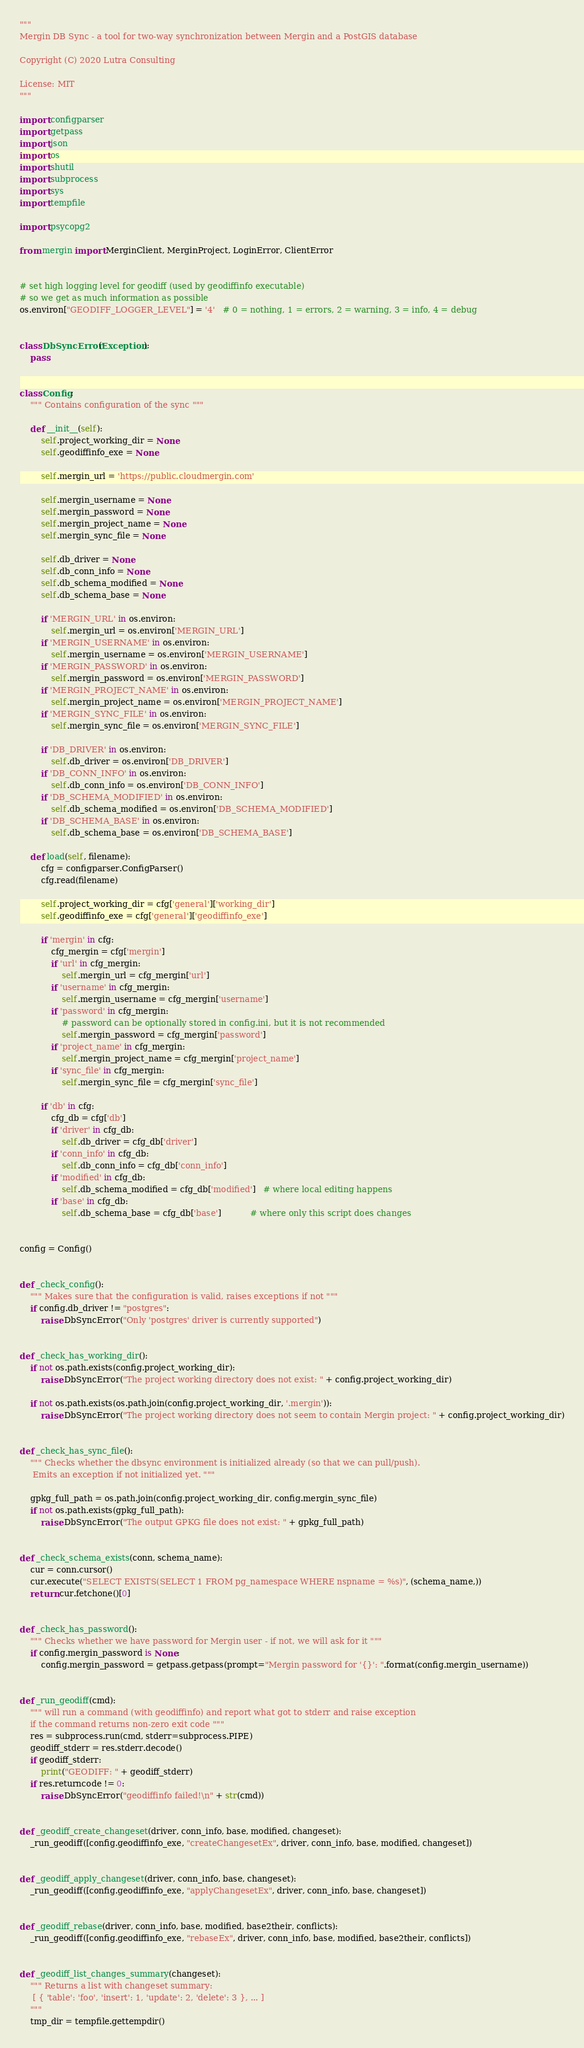<code> <loc_0><loc_0><loc_500><loc_500><_Python_>"""
Mergin DB Sync - a tool for two-way synchronization between Mergin and a PostGIS database

Copyright (C) 2020 Lutra Consulting

License: MIT
"""

import configparser
import getpass
import json
import os
import shutil
import subprocess
import sys
import tempfile

import psycopg2

from mergin import MerginClient, MerginProject, LoginError, ClientError


# set high logging level for geodiff (used by geodiffinfo executable)
# so we get as much information as possible
os.environ["GEODIFF_LOGGER_LEVEL"] = '4'   # 0 = nothing, 1 = errors, 2 = warning, 3 = info, 4 = debug


class DbSyncError(Exception):
    pass


class Config:
    """ Contains configuration of the sync """

    def __init__(self):
        self.project_working_dir = None
        self.geodiffinfo_exe = None

        self.mergin_url = 'https://public.cloudmergin.com'

        self.mergin_username = None
        self.mergin_password = None
        self.mergin_project_name = None
        self.mergin_sync_file = None

        self.db_driver = None
        self.db_conn_info = None
        self.db_schema_modified = None
        self.db_schema_base = None

        if 'MERGIN_URL' in os.environ:
            self.mergin_url = os.environ['MERGIN_URL']
        if 'MERGIN_USERNAME' in os.environ:
            self.mergin_username = os.environ['MERGIN_USERNAME']
        if 'MERGIN_PASSWORD' in os.environ:
            self.mergin_password = os.environ['MERGIN_PASSWORD']
        if 'MERGIN_PROJECT_NAME' in os.environ:
            self.mergin_project_name = os.environ['MERGIN_PROJECT_NAME']
        if 'MERGIN_SYNC_FILE' in os.environ:
            self.mergin_sync_file = os.environ['MERGIN_SYNC_FILE']

        if 'DB_DRIVER' in os.environ:
            self.db_driver = os.environ['DB_DRIVER']
        if 'DB_CONN_INFO' in os.environ:
            self.db_conn_info = os.environ['DB_CONN_INFO']
        if 'DB_SCHEMA_MODIFIED' in os.environ:
            self.db_schema_modified = os.environ['DB_SCHEMA_MODIFIED']
        if 'DB_SCHEMA_BASE' in os.environ:
            self.db_schema_base = os.environ['DB_SCHEMA_BASE']

    def load(self, filename):
        cfg = configparser.ConfigParser()
        cfg.read(filename)

        self.project_working_dir = cfg['general']['working_dir']
        self.geodiffinfo_exe = cfg['general']['geodiffinfo_exe']

        if 'mergin' in cfg:
            cfg_mergin = cfg['mergin']
            if 'url' in cfg_mergin:
                self.mergin_url = cfg_mergin['url']
            if 'username' in cfg_mergin:
                self.mergin_username = cfg_mergin['username']
            if 'password' in cfg_mergin:
                # password can be optionally stored in config.ini, but it is not recommended
                self.mergin_password = cfg_mergin['password']
            if 'project_name' in cfg_mergin:
                self.mergin_project_name = cfg_mergin['project_name']
            if 'sync_file' in cfg_mergin:
                self.mergin_sync_file = cfg_mergin['sync_file']

        if 'db' in cfg:
            cfg_db = cfg['db']
            if 'driver' in cfg_db:
                self.db_driver = cfg_db['driver']
            if 'conn_info' in cfg_db:
                self.db_conn_info = cfg_db['conn_info']
            if 'modified' in cfg_db:
                self.db_schema_modified = cfg_db['modified']   # where local editing happens
            if 'base' in cfg_db:
                self.db_schema_base = cfg_db['base']           # where only this script does changes


config = Config()


def _check_config():
    """ Makes sure that the configuration is valid, raises exceptions if not """
    if config.db_driver != "postgres":
        raise DbSyncError("Only 'postgres' driver is currently supported")


def _check_has_working_dir():
    if not os.path.exists(config.project_working_dir):
        raise DbSyncError("The project working directory does not exist: " + config.project_working_dir)

    if not os.path.exists(os.path.join(config.project_working_dir, '.mergin')):
        raise DbSyncError("The project working directory does not seem to contain Mergin project: " + config.project_working_dir)


def _check_has_sync_file():
    """ Checks whether the dbsync environment is initialized already (so that we can pull/push).
     Emits an exception if not initialized yet. """

    gpkg_full_path = os.path.join(config.project_working_dir, config.mergin_sync_file)
    if not os.path.exists(gpkg_full_path):
        raise DbSyncError("The output GPKG file does not exist: " + gpkg_full_path)


def _check_schema_exists(conn, schema_name):
    cur = conn.cursor()
    cur.execute("SELECT EXISTS(SELECT 1 FROM pg_namespace WHERE nspname = %s)", (schema_name,))
    return cur.fetchone()[0]


def _check_has_password():
    """ Checks whether we have password for Mergin user - if not, we will ask for it """
    if config.mergin_password is None:
        config.mergin_password = getpass.getpass(prompt="Mergin password for '{}': ".format(config.mergin_username))


def _run_geodiff(cmd):
    """ will run a command (with geodiffinfo) and report what got to stderr and raise exception
    if the command returns non-zero exit code """
    res = subprocess.run(cmd, stderr=subprocess.PIPE)
    geodiff_stderr = res.stderr.decode()
    if geodiff_stderr:
        print("GEODIFF: " + geodiff_stderr)
    if res.returncode != 0:
        raise DbSyncError("geodiffinfo failed!\n" + str(cmd))


def _geodiff_create_changeset(driver, conn_info, base, modified, changeset):
    _run_geodiff([config.geodiffinfo_exe, "createChangesetEx", driver, conn_info, base, modified, changeset])


def _geodiff_apply_changeset(driver, conn_info, base, changeset):
    _run_geodiff([config.geodiffinfo_exe, "applyChangesetEx", driver, conn_info, base, changeset])


def _geodiff_rebase(driver, conn_info, base, modified, base2their, conflicts):
    _run_geodiff([config.geodiffinfo_exe, "rebaseEx", driver, conn_info, base, modified, base2their, conflicts])


def _geodiff_list_changes_summary(changeset):
    """ Returns a list with changeset summary:
     [ { 'table': 'foo', 'insert': 1, 'update': 2, 'delete': 3 }, ... ]
    """
    tmp_dir = tempfile.gettempdir()</code> 